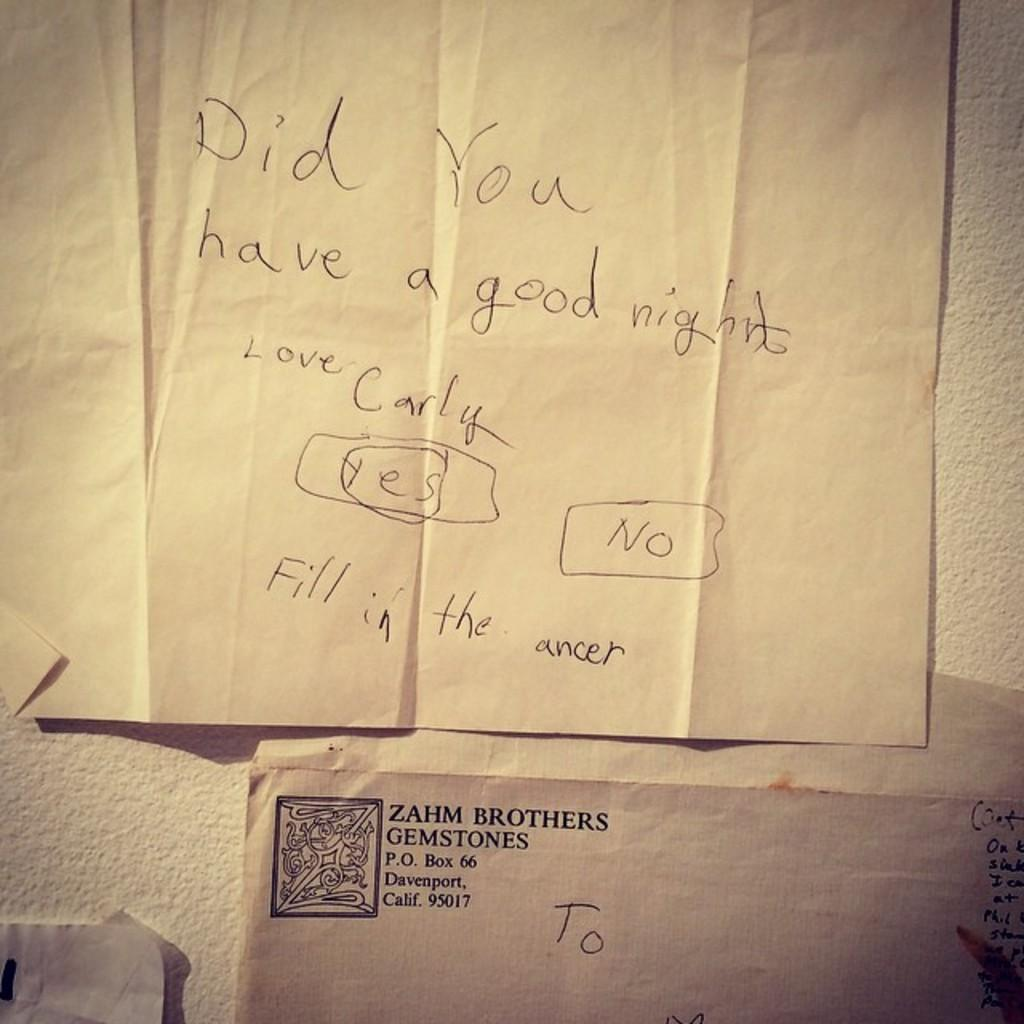<image>
Create a compact narrative representing the image presented. An envelope from Zahm brothers gemstones is from California. 